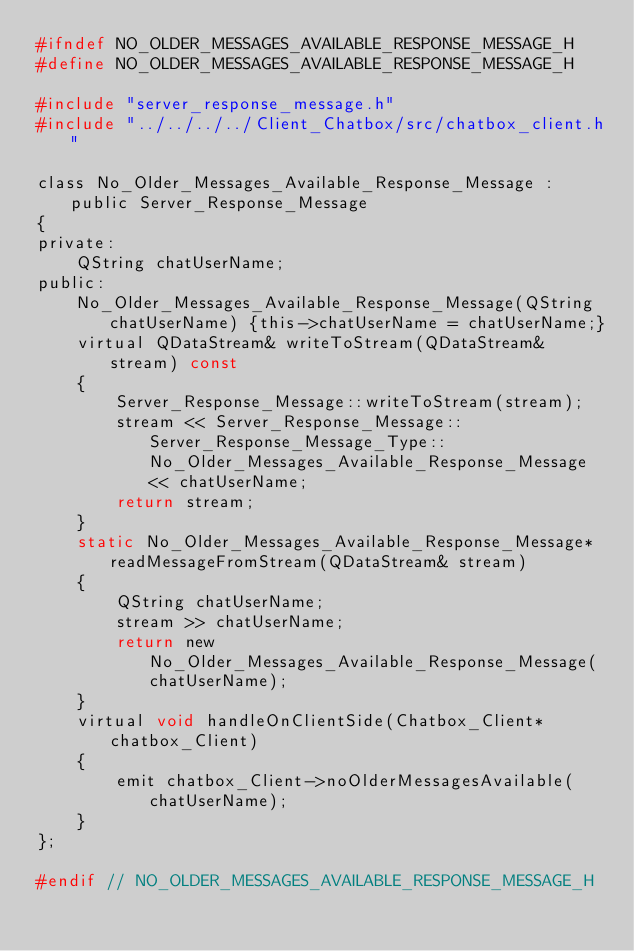Convert code to text. <code><loc_0><loc_0><loc_500><loc_500><_C_>#ifndef NO_OLDER_MESSAGES_AVAILABLE_RESPONSE_MESSAGE_H
#define NO_OLDER_MESSAGES_AVAILABLE_RESPONSE_MESSAGE_H

#include "server_response_message.h"
#include "../../../../Client_Chatbox/src/chatbox_client.h"

class No_Older_Messages_Available_Response_Message : public Server_Response_Message
{
private:
    QString chatUserName;
public:
    No_Older_Messages_Available_Response_Message(QString chatUserName) {this->chatUserName = chatUserName;}
    virtual QDataStream& writeToStream(QDataStream& stream) const
    {
        Server_Response_Message::writeToStream(stream);
        stream << Server_Response_Message::Server_Response_Message_Type::No_Older_Messages_Available_Response_Message << chatUserName;
        return stream;
    }
    static No_Older_Messages_Available_Response_Message* readMessageFromStream(QDataStream& stream)
    {
        QString chatUserName;
        stream >> chatUserName;
        return new No_Older_Messages_Available_Response_Message(chatUserName);
    }
    virtual void handleOnClientSide(Chatbox_Client* chatbox_Client)
    {
        emit chatbox_Client->noOlderMessagesAvailable(chatUserName);
    }
};

#endif // NO_OLDER_MESSAGES_AVAILABLE_RESPONSE_MESSAGE_H
</code> 